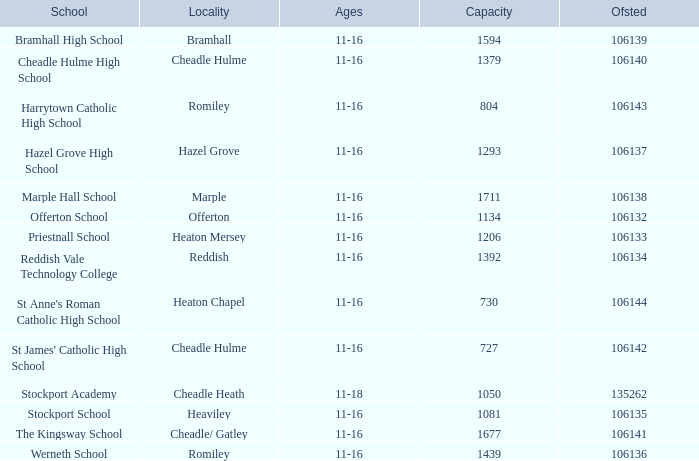What school serves 11-16 year olds, possesses an ofsted number below 106142, and can accommodate 1206 students? Priestnall School. 